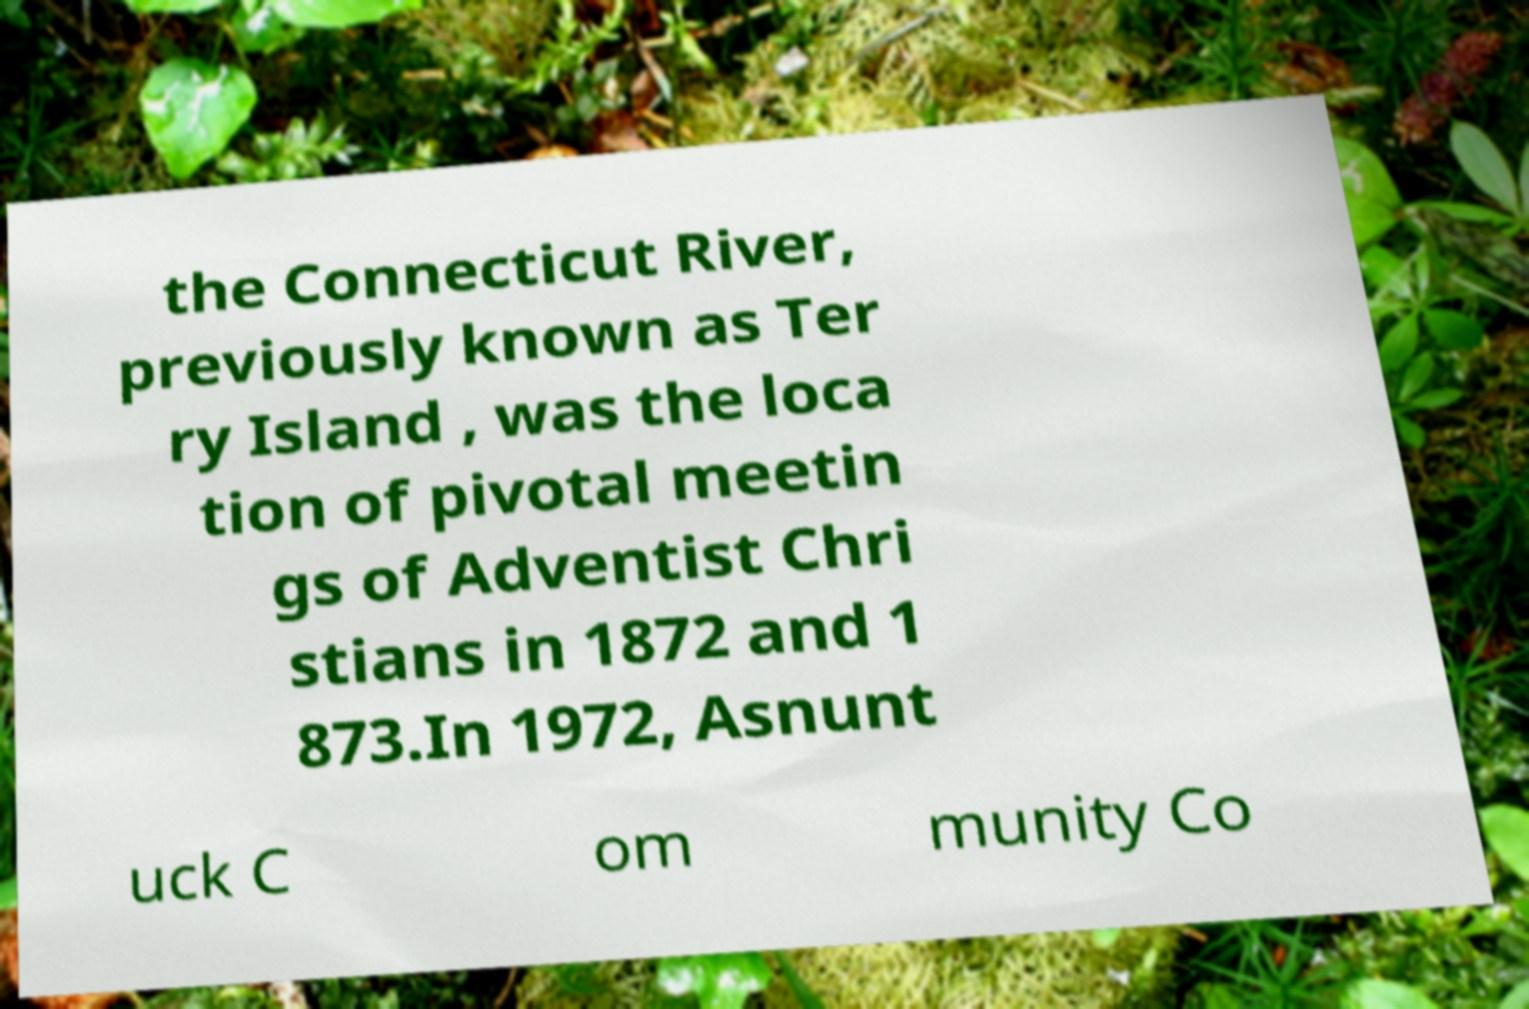Please identify and transcribe the text found in this image. the Connecticut River, previously known as Ter ry Island , was the loca tion of pivotal meetin gs of Adventist Chri stians in 1872 and 1 873.In 1972, Asnunt uck C om munity Co 